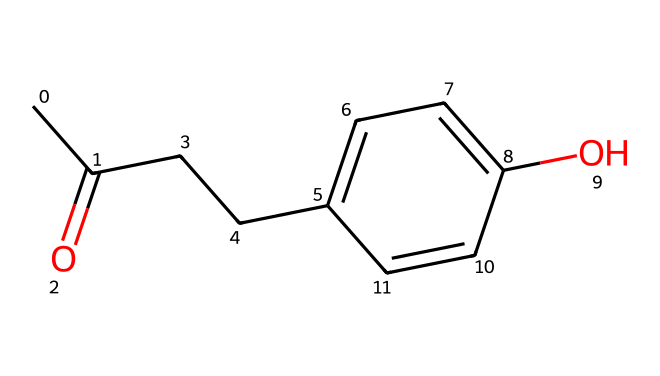How many carbon atoms are present in raspberry ketone? By analyzing the SMILES representation, we can count the carbon (C) atoms. The structure indicates there are a total of 9 carbon atoms through the main chain and the aromatic ring.
Answer: 9 What functional group characterizes raspberry ketone? The presence of a carbonyl group (C=O) in the structure denotes that this chemical is a ketone. The carbonyl carbon is part of the main carbon chain which signifies its classification.
Answer: ketone What is the molecular formula for raspberry ketone? The SMILES representation can be translated into the molecular formula by tallying the atoms: 9 carbons, 10 hydrogens, and 2 oxygens, leading to the formula C9H10O2.
Answer: C9H10O2 How many oxygen atoms are found in raspberry ketone? Observing the SMILES representation, there are two instances in the structure where oxygen (O) appears, indicating there are two oxygen atoms in total.
Answer: 2 What type of reaction could raspberry ketone participate in due to the carbonyl group? The carbonyl group present in the ketone makes it susceptible to nucleophilic addition reactions, wherein nucleophiles can attack the electrophilic carbon of the carbonyl.
Answer: nucleophilic addition What type of aroma or flavor does raspberry ketone impart? The structure of raspberry ketone is associated with a sweet and fruity aroma, resembling that of raspberries; this characteristic makes it popular in flavoring snack foods.
Answer: fruity What is the boiling point of raspberry ketone approximately? Based on literature and known data on similar ketones, raspberry ketone has a boiling point of around 200 degrees Celsius, which can often be inferred based on the structure type.
Answer: 200 degrees Celsius 